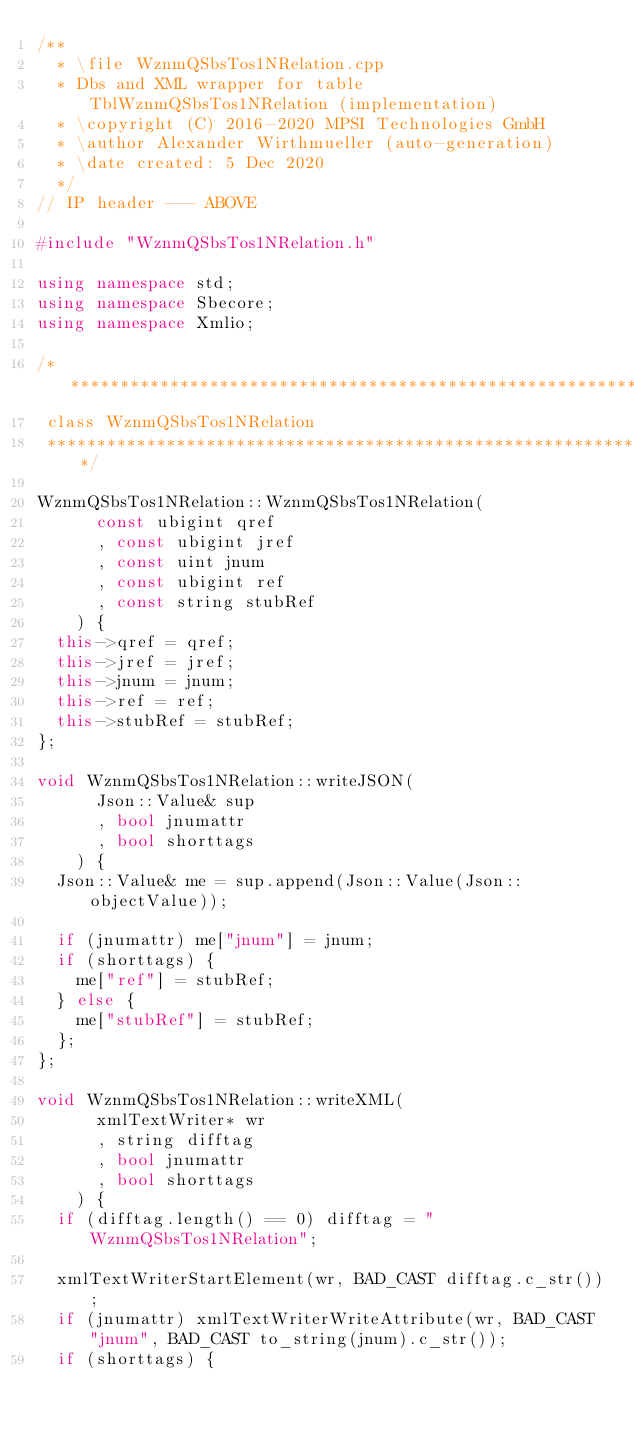<code> <loc_0><loc_0><loc_500><loc_500><_C++_>/**
	* \file WznmQSbsTos1NRelation.cpp
	* Dbs and XML wrapper for table TblWznmQSbsTos1NRelation (implementation)
	* \copyright (C) 2016-2020 MPSI Technologies GmbH
	* \author Alexander Wirthmueller (auto-generation)
	* \date created: 5 Dec 2020
  */
// IP header --- ABOVE

#include "WznmQSbsTos1NRelation.h"

using namespace std;
using namespace Sbecore;
using namespace Xmlio;

/******************************************************************************
 class WznmQSbsTos1NRelation
 ******************************************************************************/

WznmQSbsTos1NRelation::WznmQSbsTos1NRelation(
			const ubigint qref
			, const ubigint jref
			, const uint jnum
			, const ubigint ref
			, const string stubRef
		) {
	this->qref = qref;
	this->jref = jref;
	this->jnum = jnum;
	this->ref = ref;
	this->stubRef = stubRef;
};

void WznmQSbsTos1NRelation::writeJSON(
			Json::Value& sup
			, bool jnumattr
			, bool shorttags
		) {
	Json::Value& me = sup.append(Json::Value(Json::objectValue));

	if (jnumattr) me["jnum"] = jnum;
	if (shorttags) {
		me["ref"] = stubRef;
	} else {
		me["stubRef"] = stubRef;
	};
};

void WznmQSbsTos1NRelation::writeXML(
			xmlTextWriter* wr
			, string difftag
			, bool jnumattr
			, bool shorttags
		) {
	if (difftag.length() == 0) difftag = "WznmQSbsTos1NRelation";

	xmlTextWriterStartElement(wr, BAD_CAST difftag.c_str());
	if (jnumattr) xmlTextWriterWriteAttribute(wr, BAD_CAST "jnum", BAD_CAST to_string(jnum).c_str());
	if (shorttags) {</code> 